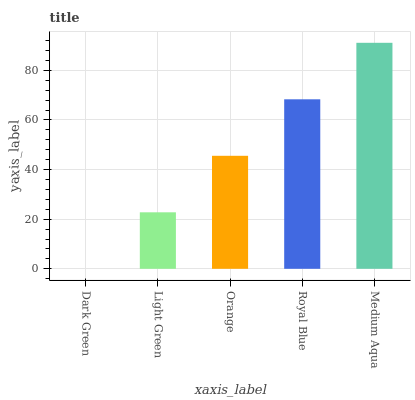Is Light Green the minimum?
Answer yes or no. No. Is Light Green the maximum?
Answer yes or no. No. Is Light Green greater than Dark Green?
Answer yes or no. Yes. Is Dark Green less than Light Green?
Answer yes or no. Yes. Is Dark Green greater than Light Green?
Answer yes or no. No. Is Light Green less than Dark Green?
Answer yes or no. No. Is Orange the high median?
Answer yes or no. Yes. Is Orange the low median?
Answer yes or no. Yes. Is Medium Aqua the high median?
Answer yes or no. No. Is Medium Aqua the low median?
Answer yes or no. No. 